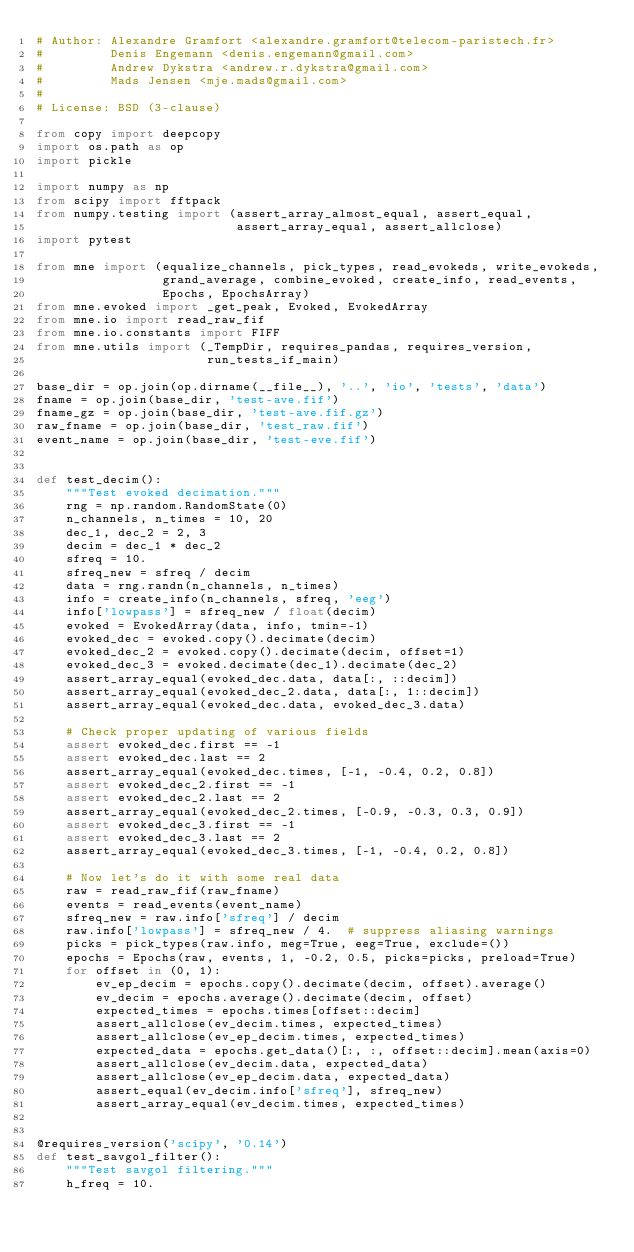<code> <loc_0><loc_0><loc_500><loc_500><_Python_># Author: Alexandre Gramfort <alexandre.gramfort@telecom-paristech.fr>
#         Denis Engemann <denis.engemann@gmail.com>
#         Andrew Dykstra <andrew.r.dykstra@gmail.com>
#         Mads Jensen <mje.mads@gmail.com>
#
# License: BSD (3-clause)

from copy import deepcopy
import os.path as op
import pickle

import numpy as np
from scipy import fftpack
from numpy.testing import (assert_array_almost_equal, assert_equal,
                           assert_array_equal, assert_allclose)
import pytest

from mne import (equalize_channels, pick_types, read_evokeds, write_evokeds,
                 grand_average, combine_evoked, create_info, read_events,
                 Epochs, EpochsArray)
from mne.evoked import _get_peak, Evoked, EvokedArray
from mne.io import read_raw_fif
from mne.io.constants import FIFF
from mne.utils import (_TempDir, requires_pandas, requires_version,
                       run_tests_if_main)

base_dir = op.join(op.dirname(__file__), '..', 'io', 'tests', 'data')
fname = op.join(base_dir, 'test-ave.fif')
fname_gz = op.join(base_dir, 'test-ave.fif.gz')
raw_fname = op.join(base_dir, 'test_raw.fif')
event_name = op.join(base_dir, 'test-eve.fif')


def test_decim():
    """Test evoked decimation."""
    rng = np.random.RandomState(0)
    n_channels, n_times = 10, 20
    dec_1, dec_2 = 2, 3
    decim = dec_1 * dec_2
    sfreq = 10.
    sfreq_new = sfreq / decim
    data = rng.randn(n_channels, n_times)
    info = create_info(n_channels, sfreq, 'eeg')
    info['lowpass'] = sfreq_new / float(decim)
    evoked = EvokedArray(data, info, tmin=-1)
    evoked_dec = evoked.copy().decimate(decim)
    evoked_dec_2 = evoked.copy().decimate(decim, offset=1)
    evoked_dec_3 = evoked.decimate(dec_1).decimate(dec_2)
    assert_array_equal(evoked_dec.data, data[:, ::decim])
    assert_array_equal(evoked_dec_2.data, data[:, 1::decim])
    assert_array_equal(evoked_dec.data, evoked_dec_3.data)

    # Check proper updating of various fields
    assert evoked_dec.first == -1
    assert evoked_dec.last == 2
    assert_array_equal(evoked_dec.times, [-1, -0.4, 0.2, 0.8])
    assert evoked_dec_2.first == -1
    assert evoked_dec_2.last == 2
    assert_array_equal(evoked_dec_2.times, [-0.9, -0.3, 0.3, 0.9])
    assert evoked_dec_3.first == -1
    assert evoked_dec_3.last == 2
    assert_array_equal(evoked_dec_3.times, [-1, -0.4, 0.2, 0.8])

    # Now let's do it with some real data
    raw = read_raw_fif(raw_fname)
    events = read_events(event_name)
    sfreq_new = raw.info['sfreq'] / decim
    raw.info['lowpass'] = sfreq_new / 4.  # suppress aliasing warnings
    picks = pick_types(raw.info, meg=True, eeg=True, exclude=())
    epochs = Epochs(raw, events, 1, -0.2, 0.5, picks=picks, preload=True)
    for offset in (0, 1):
        ev_ep_decim = epochs.copy().decimate(decim, offset).average()
        ev_decim = epochs.average().decimate(decim, offset)
        expected_times = epochs.times[offset::decim]
        assert_allclose(ev_decim.times, expected_times)
        assert_allclose(ev_ep_decim.times, expected_times)
        expected_data = epochs.get_data()[:, :, offset::decim].mean(axis=0)
        assert_allclose(ev_decim.data, expected_data)
        assert_allclose(ev_ep_decim.data, expected_data)
        assert_equal(ev_decim.info['sfreq'], sfreq_new)
        assert_array_equal(ev_decim.times, expected_times)


@requires_version('scipy', '0.14')
def test_savgol_filter():
    """Test savgol filtering."""
    h_freq = 10.</code> 